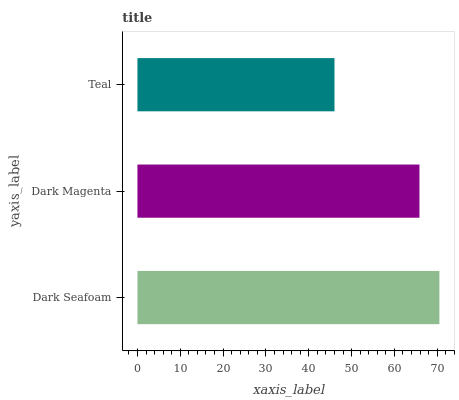Is Teal the minimum?
Answer yes or no. Yes. Is Dark Seafoam the maximum?
Answer yes or no. Yes. Is Dark Magenta the minimum?
Answer yes or no. No. Is Dark Magenta the maximum?
Answer yes or no. No. Is Dark Seafoam greater than Dark Magenta?
Answer yes or no. Yes. Is Dark Magenta less than Dark Seafoam?
Answer yes or no. Yes. Is Dark Magenta greater than Dark Seafoam?
Answer yes or no. No. Is Dark Seafoam less than Dark Magenta?
Answer yes or no. No. Is Dark Magenta the high median?
Answer yes or no. Yes. Is Dark Magenta the low median?
Answer yes or no. Yes. Is Dark Seafoam the high median?
Answer yes or no. No. Is Teal the low median?
Answer yes or no. No. 